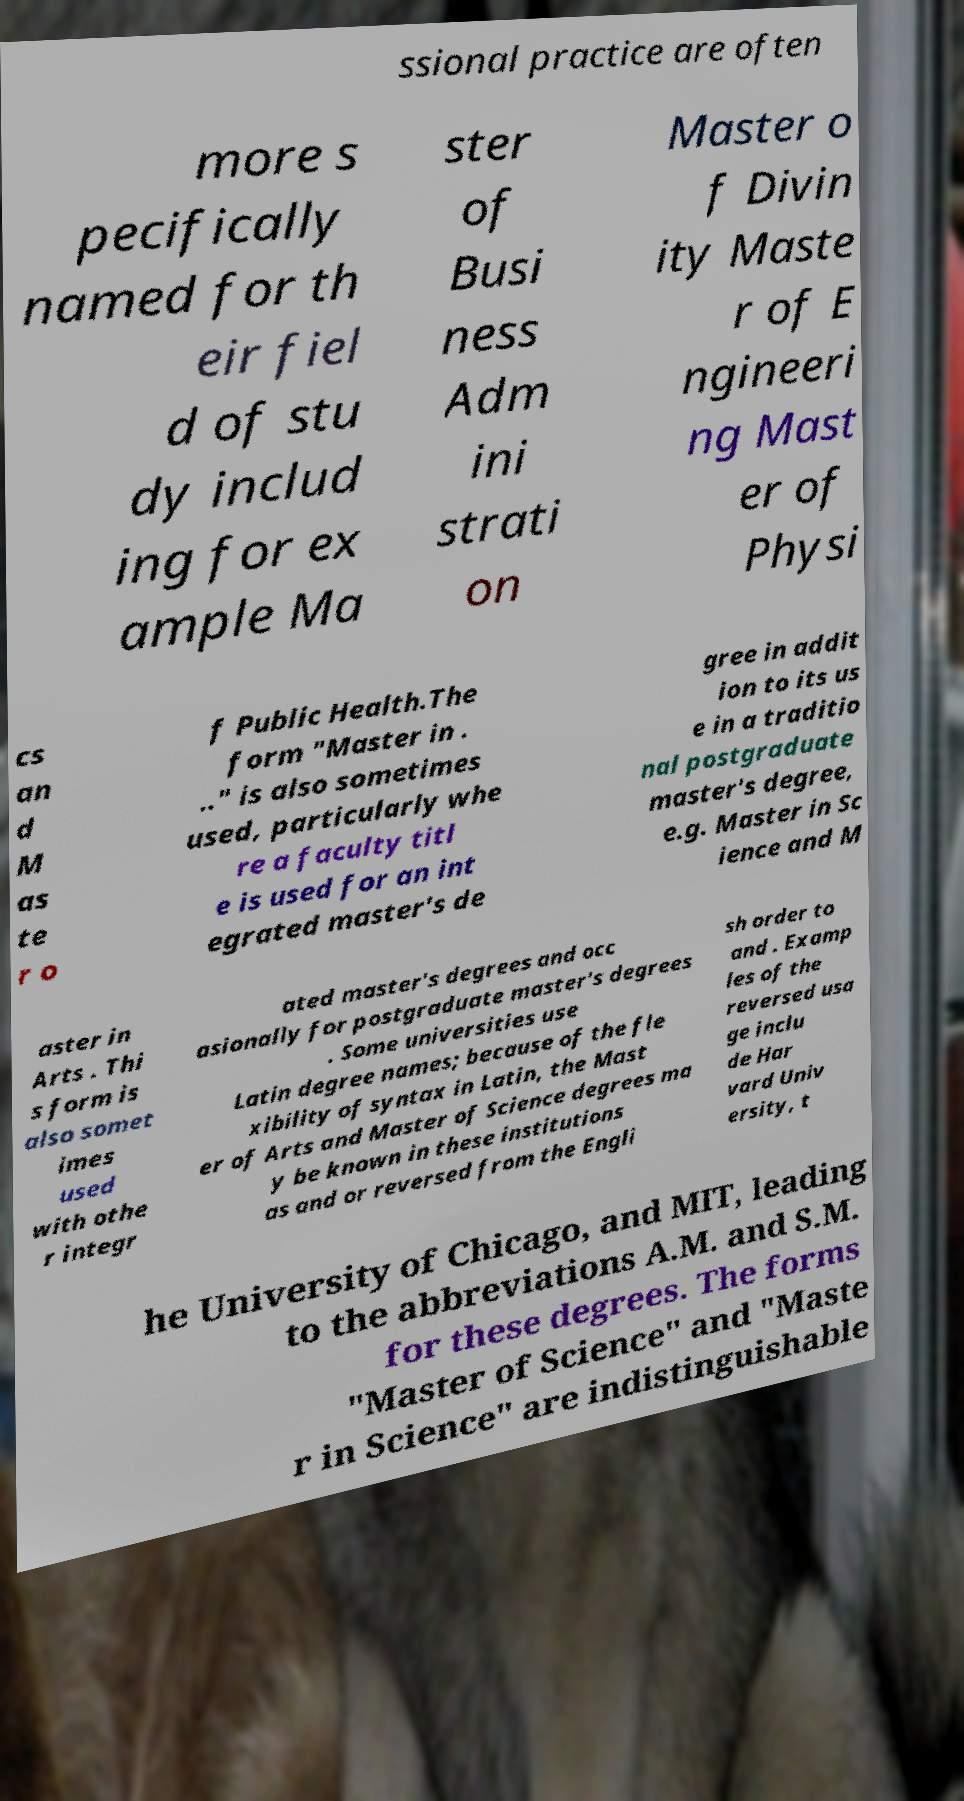Could you extract and type out the text from this image? ssional practice are often more s pecifically named for th eir fiel d of stu dy includ ing for ex ample Ma ster of Busi ness Adm ini strati on Master o f Divin ity Maste r of E ngineeri ng Mast er of Physi cs an d M as te r o f Public Health.The form "Master in . .." is also sometimes used, particularly whe re a faculty titl e is used for an int egrated master's de gree in addit ion to its us e in a traditio nal postgraduate master's degree, e.g. Master in Sc ience and M aster in Arts . Thi s form is also somet imes used with othe r integr ated master's degrees and occ asionally for postgraduate master's degrees . Some universities use Latin degree names; because of the fle xibility of syntax in Latin, the Mast er of Arts and Master of Science degrees ma y be known in these institutions as and or reversed from the Engli sh order to and . Examp les of the reversed usa ge inclu de Har vard Univ ersity, t he University of Chicago, and MIT, leading to the abbreviations A.M. and S.M. for these degrees. The forms "Master of Science" and "Maste r in Science" are indistinguishable 